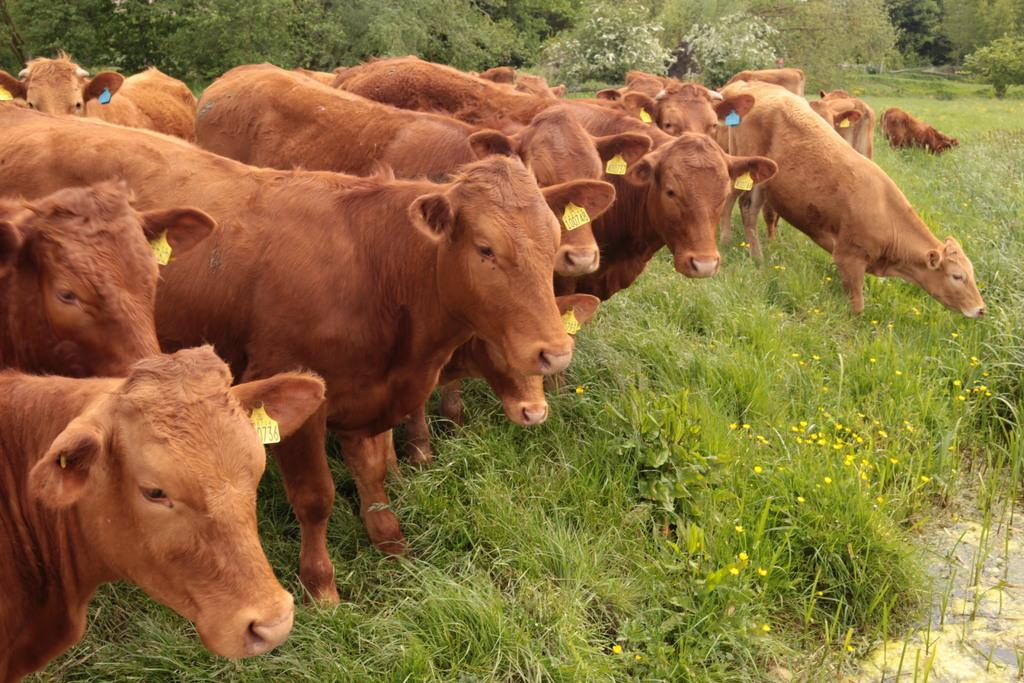What type of living organisms are present in the image? There are animals in the image. What is the color of the animals? The animals are brown in color. What can be seen in the background of the image? There is grass and trees in the background of the image. What is the color of the grass and trees? The grass and trees are green in color. What type of peace treaty is being signed by the animals in the image? There is no indication in the image that the animals are signing a peace treaty or engaging in any human-like activities. 